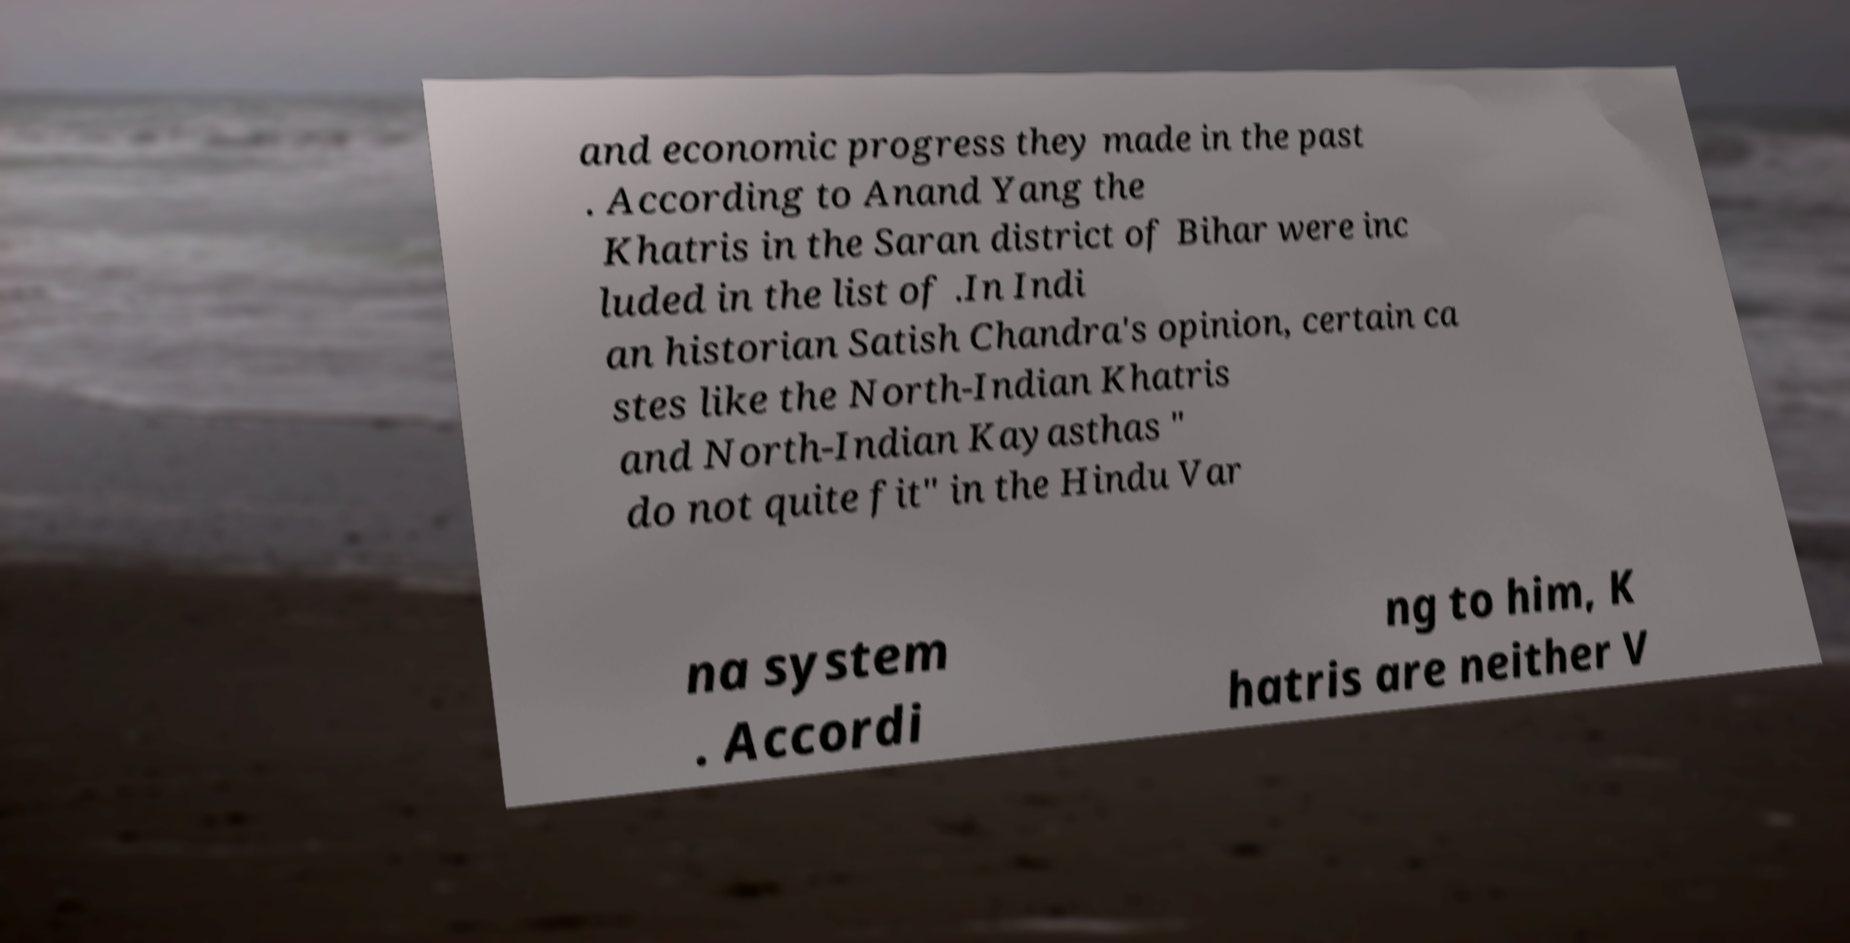There's text embedded in this image that I need extracted. Can you transcribe it verbatim? and economic progress they made in the past . According to Anand Yang the Khatris in the Saran district of Bihar were inc luded in the list of .In Indi an historian Satish Chandra's opinion, certain ca stes like the North-Indian Khatris and North-Indian Kayasthas " do not quite fit" in the Hindu Var na system . Accordi ng to him, K hatris are neither V 